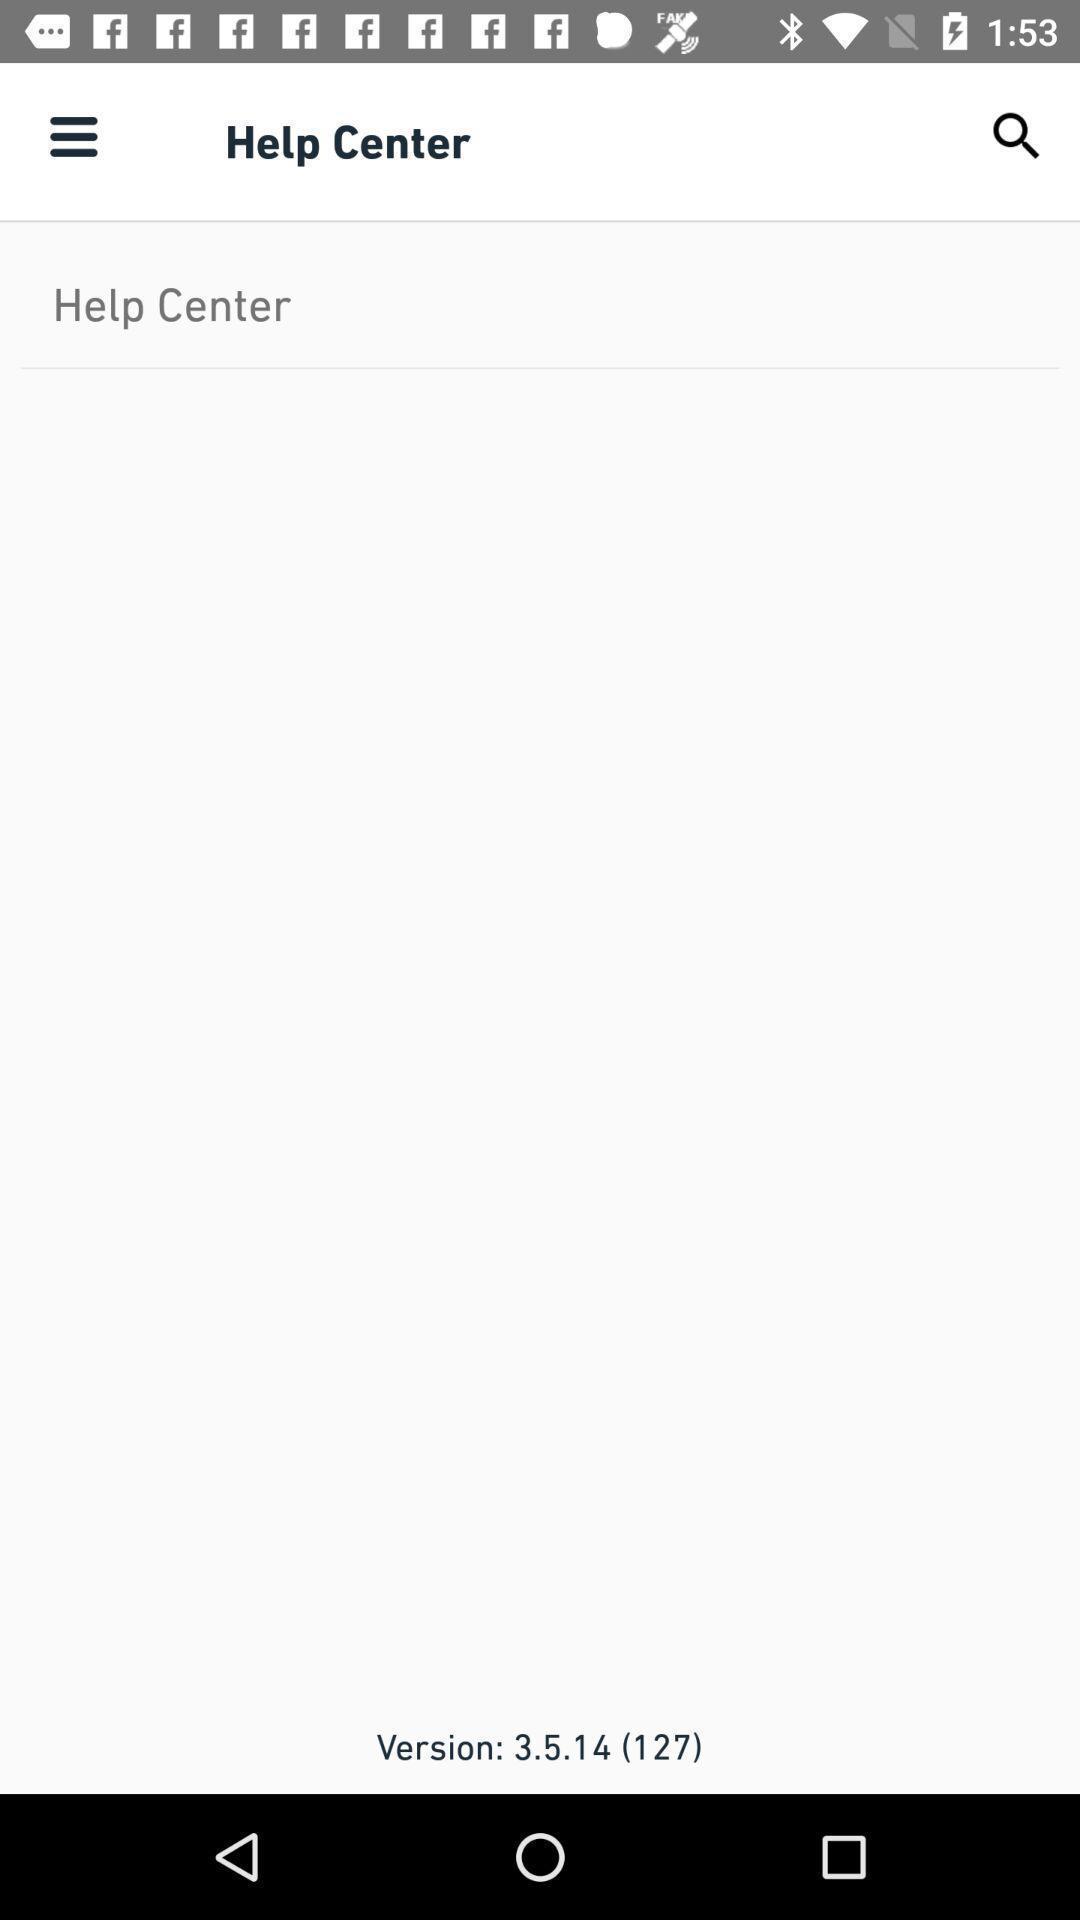What is the overall content of this screenshot? Page shows the help center info on food app. 